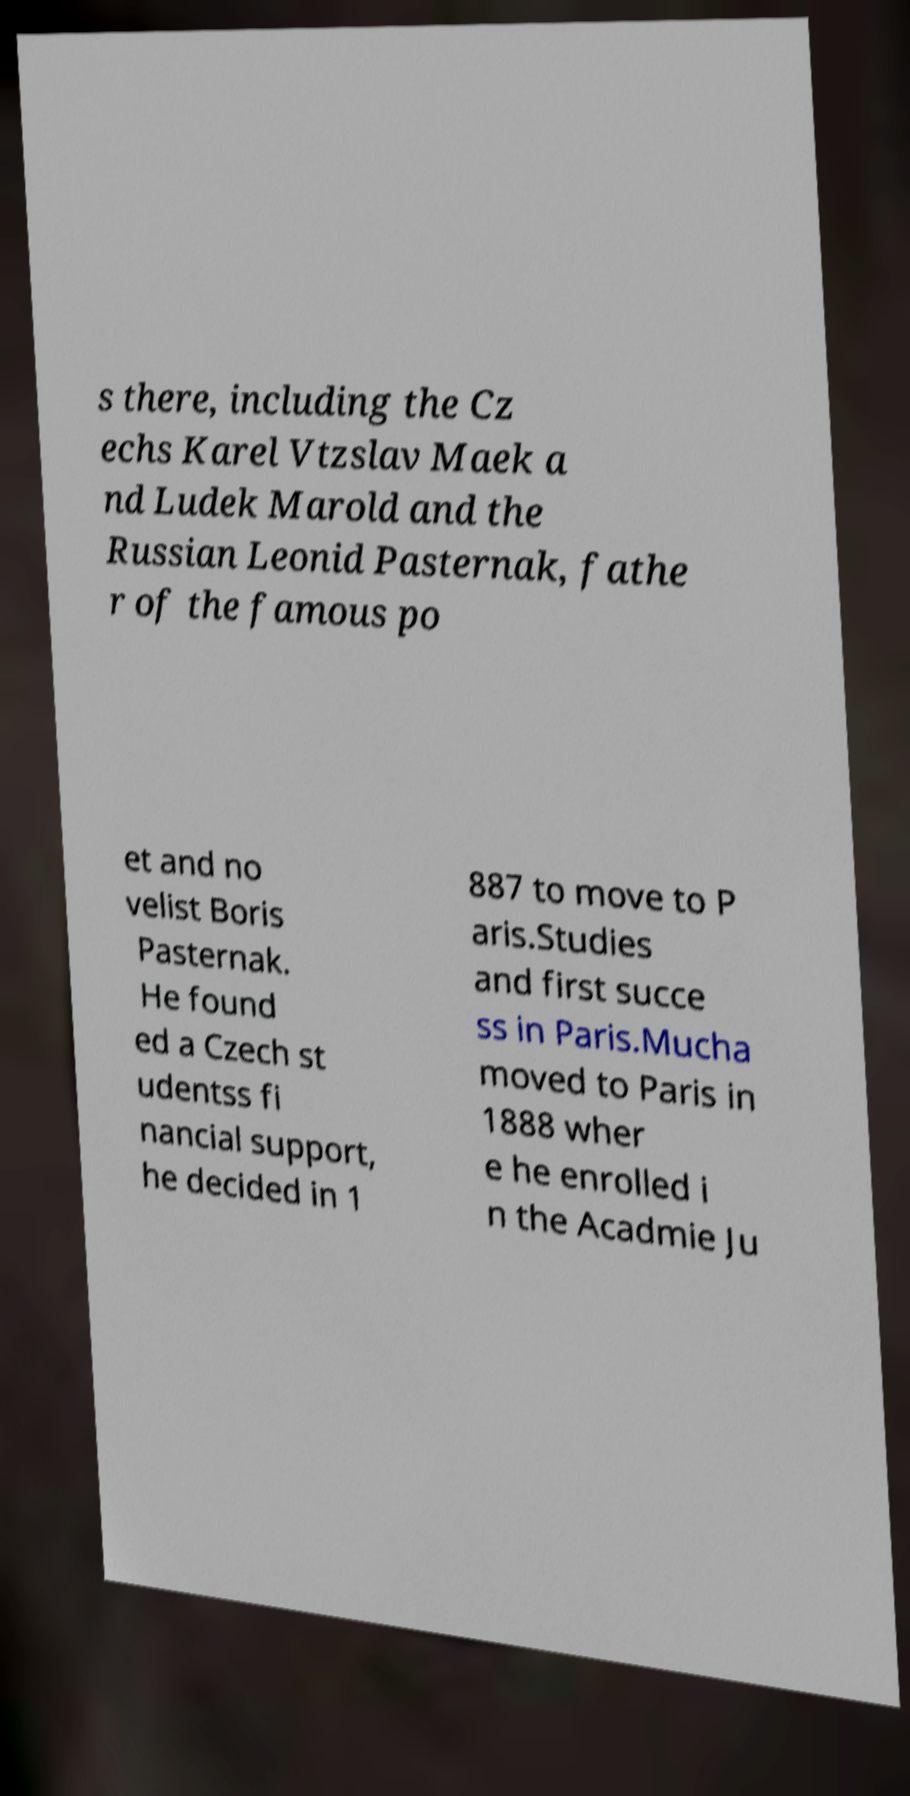What messages or text are displayed in this image? I need them in a readable, typed format. s there, including the Cz echs Karel Vtzslav Maek a nd Ludek Marold and the Russian Leonid Pasternak, fathe r of the famous po et and no velist Boris Pasternak. He found ed a Czech st udentss fi nancial support, he decided in 1 887 to move to P aris.Studies and first succe ss in Paris.Mucha moved to Paris in 1888 wher e he enrolled i n the Acadmie Ju 